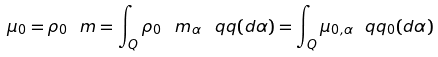<formula> <loc_0><loc_0><loc_500><loc_500>\mu _ { 0 } = \rho _ { 0 } \ m = \int _ { Q } \rho _ { 0 } \, \ m _ { \alpha } \, \ q q ( d \alpha ) = \int _ { Q } \mu _ { 0 , \alpha } \ q q _ { 0 } ( d \alpha )</formula> 